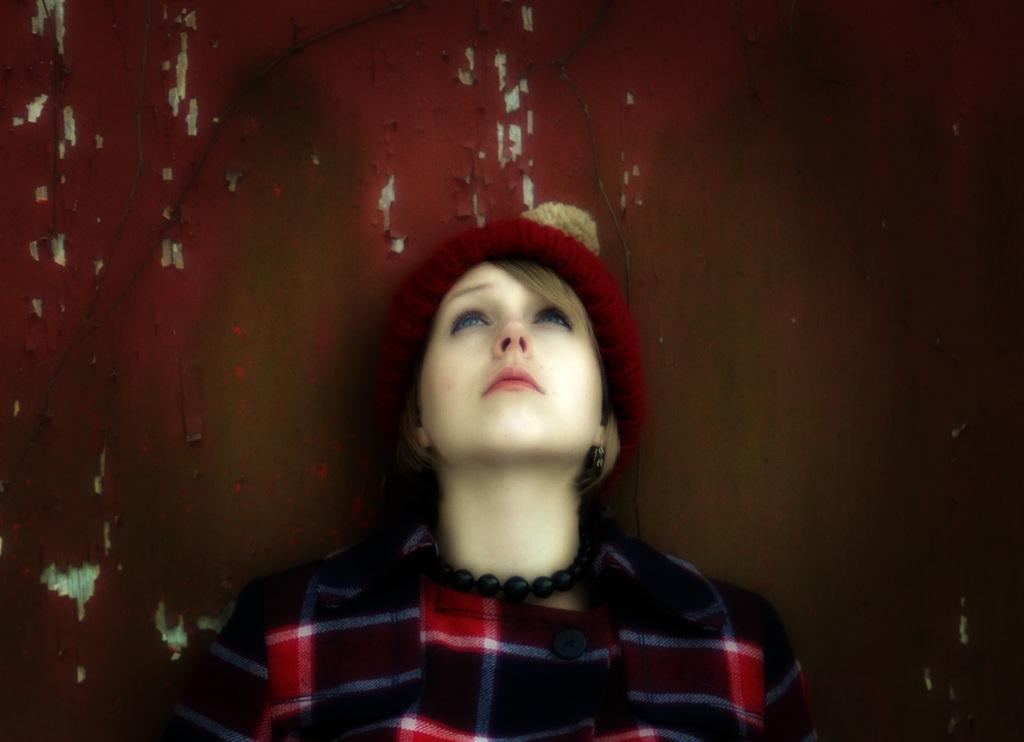What is the main subject of the image? The main subject of the image is a woman. What is the woman wearing on her head? The woman is wearing a red cap. What can be seen in the background of the image? There is a wall in the background of the image. How many kittens are playing with the lace on the wall in the image? There are no kittens or lace present in the image. 